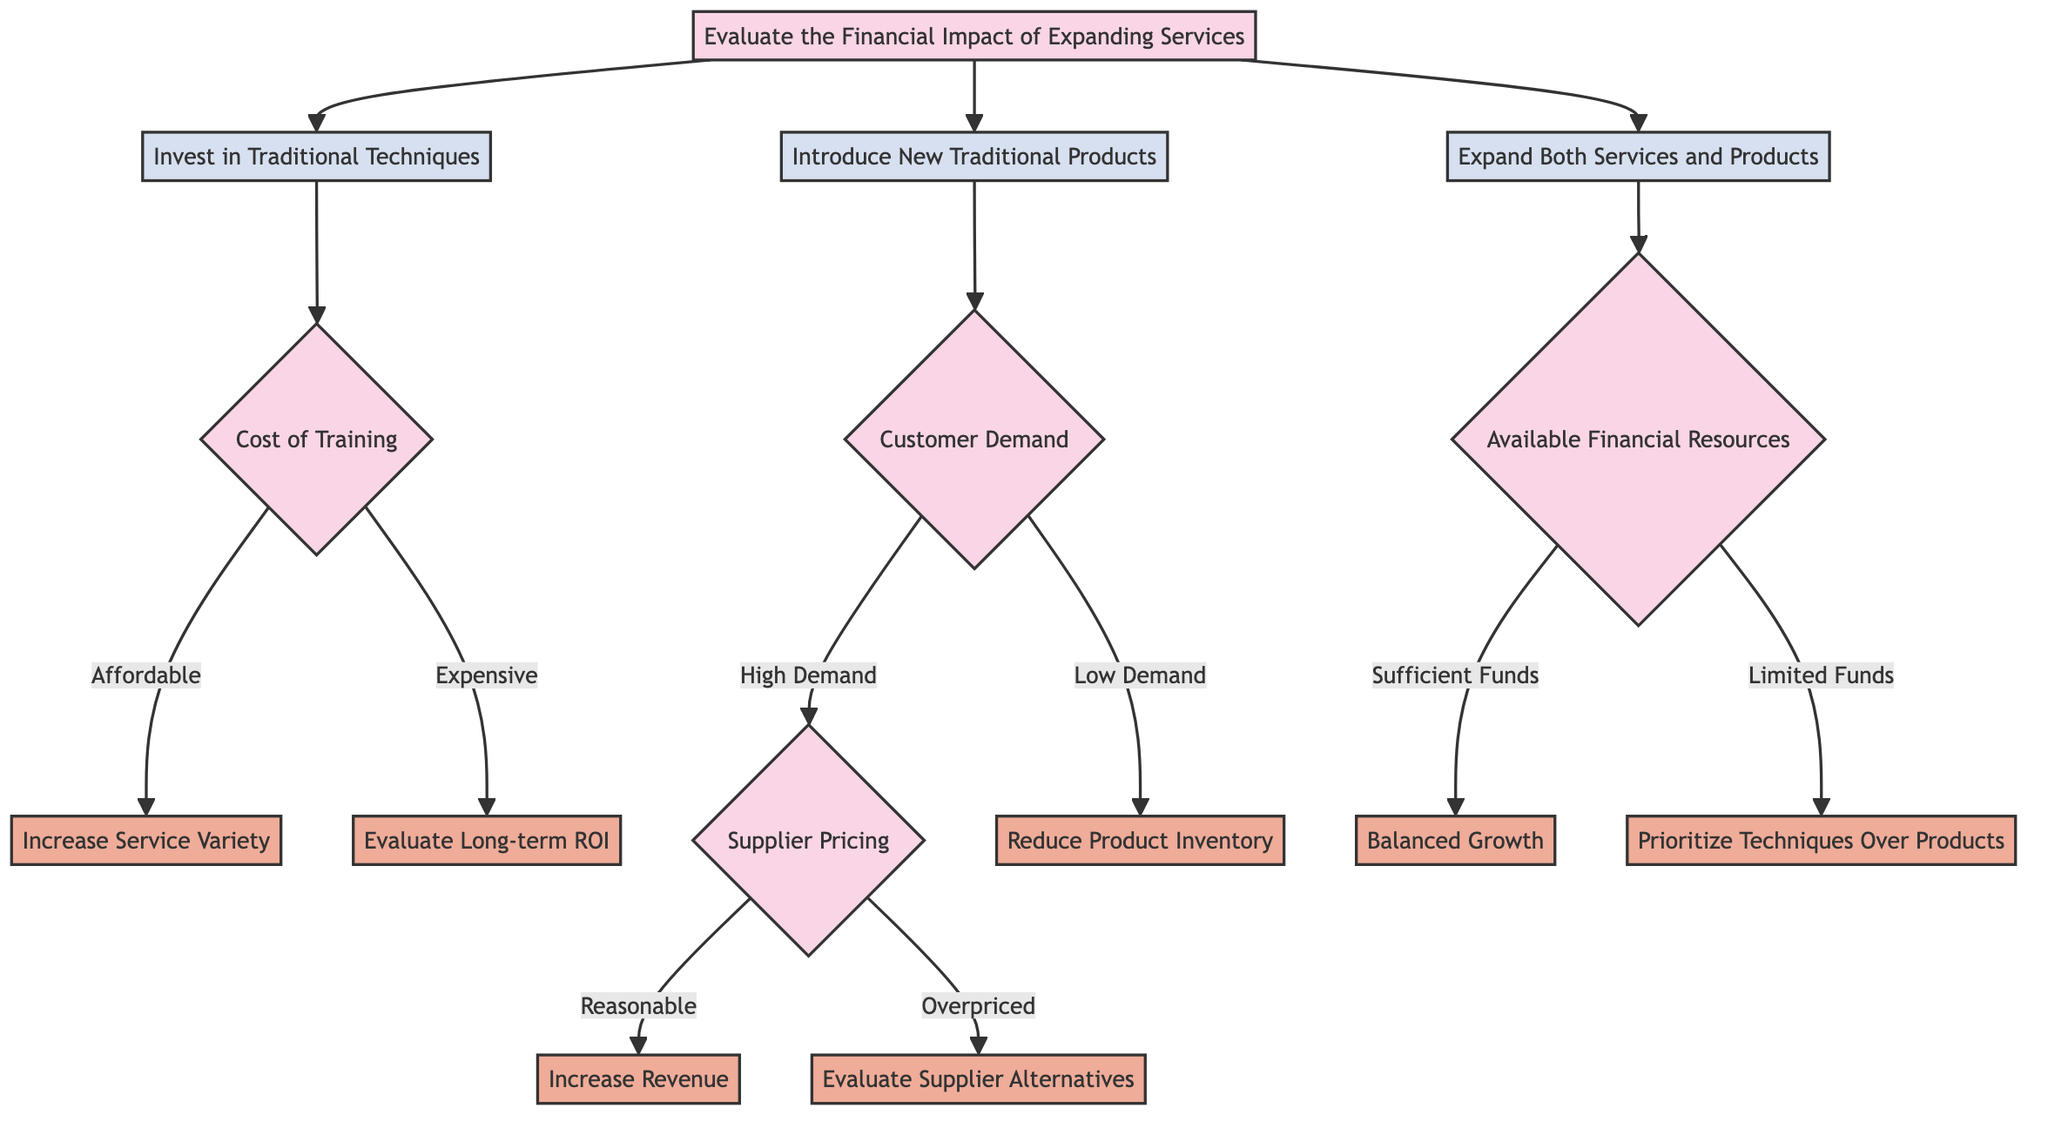What is the first question in the diagram? The first question in the diagram is located at the top node, which asks to evaluate the financial impact of expanding services.
Answer: Evaluate the Financial Impact of Expanding Services How many outcomes are there under "Invest in Traditional Techniques"? There are two outcomes under "Invest in Traditional Techniques," which are "Increase Service Variety" and "Evaluate Long-term ROI."
Answer: 2 What choice leads to "Reduce Product Inventory"? The choice that leads to "Reduce Product Inventory" is "Introduce New Traditional Products," specifically when the customer demand is evaluated as low.
Answer: Introduce New Traditional Products What is the outcome if the cost of training is expensive? If the cost of training is expensive, the outcome is to "Evaluate Long-term ROI," suggesting a careful analysis before making further commitments.
Answer: Evaluate Long-term ROI What happens if there are sufficient funds available for expanding services and products? If there are sufficient funds available, the outcome is "Balanced Growth," indicating a favorable position for expanding both services and products.
Answer: Balanced Growth Which question follows after determining that customer demand is high? After determining that customer demand is high, the next question to address is "Supplier Pricing," which will guide decisions based on cost factors of the suppliers.
Answer: Supplier Pricing How does the decision tree categorize the financial resources available? The decision tree categorizes the financial resources as either "Sufficient Funds" or "Limited Funds," which influence how the barber can proceed with expansion.
Answer: Sufficient Funds or Limited Funds What does the diagram suggest if the supplier pricing is reasonable? If the supplier pricing is reasonable, the diagram suggests the outcome is to "Increase Revenue," indicating a positive financial impact from new products.
Answer: Increase Revenue 